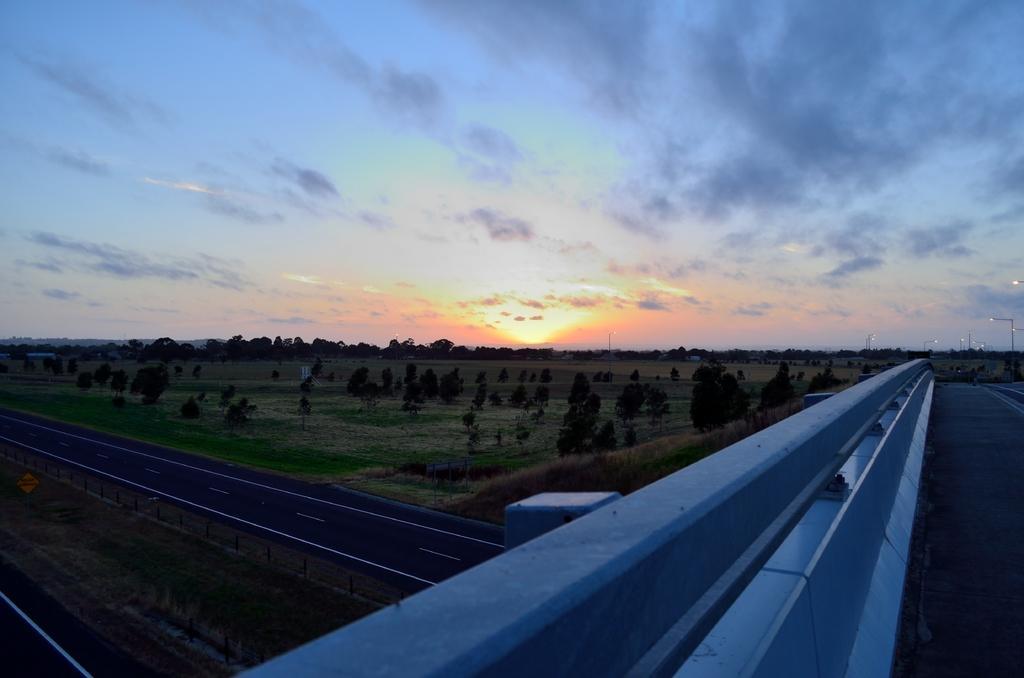In one or two sentences, can you explain what this image depicts? On the right side, there is a road on the flyover which is having a fence. On the left side, there is a divider. On both sides of the divider, there is a road. In the background, there are trees, plants and grass on the ground and there are clouds in the sky. 